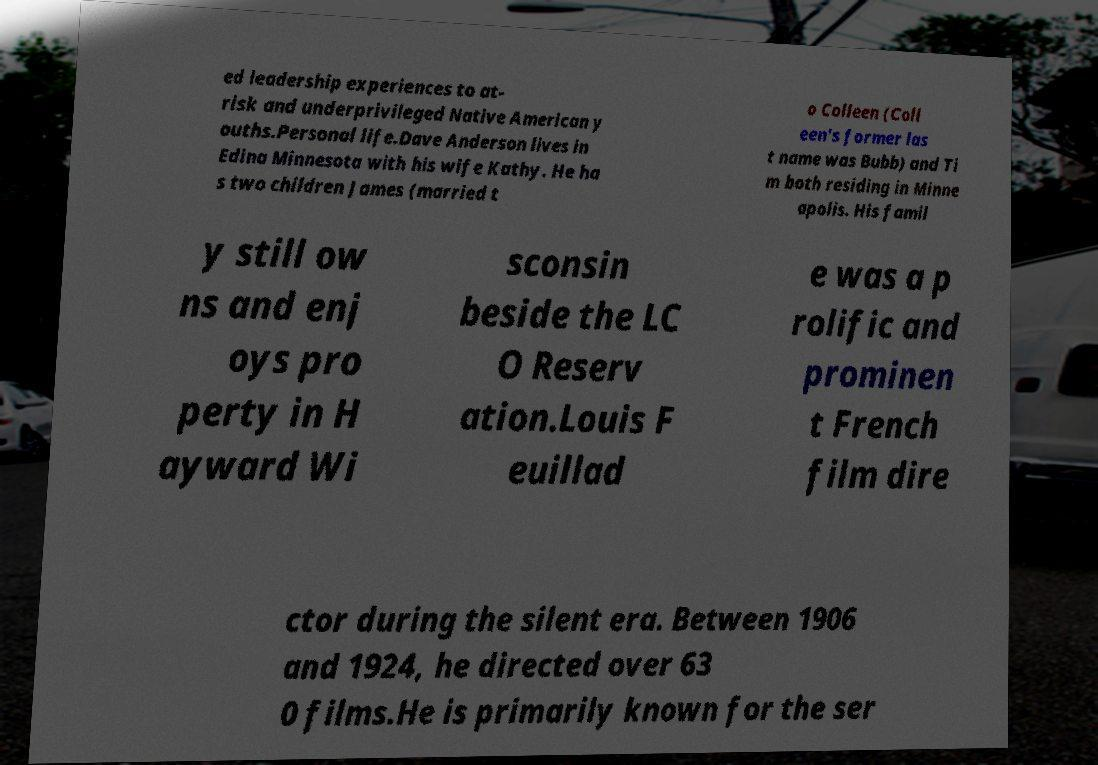I need the written content from this picture converted into text. Can you do that? ed leadership experiences to at- risk and underprivileged Native American y ouths.Personal life.Dave Anderson lives in Edina Minnesota with his wife Kathy. He ha s two children James (married t o Colleen (Coll een's former las t name was Bubb) and Ti m both residing in Minne apolis. His famil y still ow ns and enj oys pro perty in H ayward Wi sconsin beside the LC O Reserv ation.Louis F euillad e was a p rolific and prominen t French film dire ctor during the silent era. Between 1906 and 1924, he directed over 63 0 films.He is primarily known for the ser 